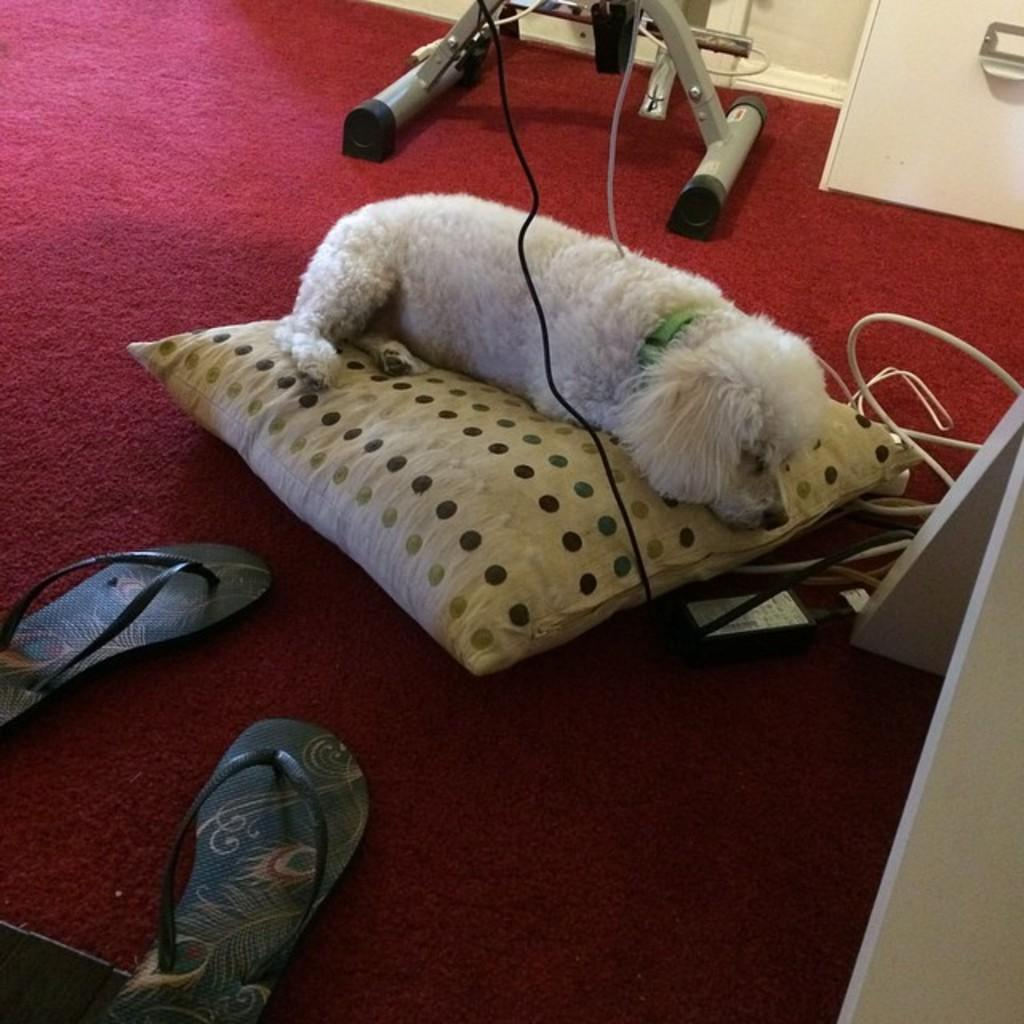What animal can be seen in the image? There is a dog in the image. What is the dog doing in the image? The dog is lying on a pillow. What type of footwear is present in the image? There is a pair of slippers in the image. What color is the carpet on which the slippers are placed? The slippers are on a red color carpet. What is the color of the dog in the image? The dog is white in color. How many eyes does the stranger have in the image? There is no stranger present in the image, so it is not possible to determine the number of eyes they might have. 